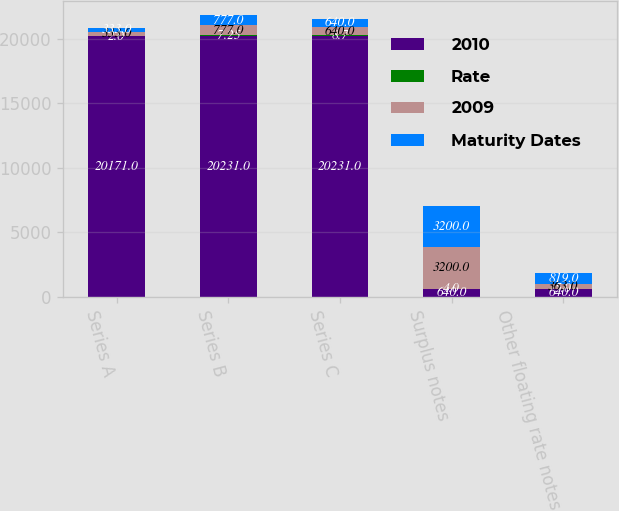Convert chart to OTSL. <chart><loc_0><loc_0><loc_500><loc_500><stacked_bar_chart><ecel><fcel>Series A<fcel>Series B<fcel>Series C<fcel>Surplus notes<fcel>Other floating rate notes<nl><fcel>2010<fcel>20171<fcel>20231<fcel>20231<fcel>640<fcel>640<nl><fcel>Rate<fcel>2<fcel>7.25<fcel>8.7<fcel>4<fcel>5<nl><fcel>2009<fcel>333<fcel>777<fcel>640<fcel>3200<fcel>363<nl><fcel>Maturity Dates<fcel>333<fcel>777<fcel>640<fcel>3200<fcel>819<nl></chart> 